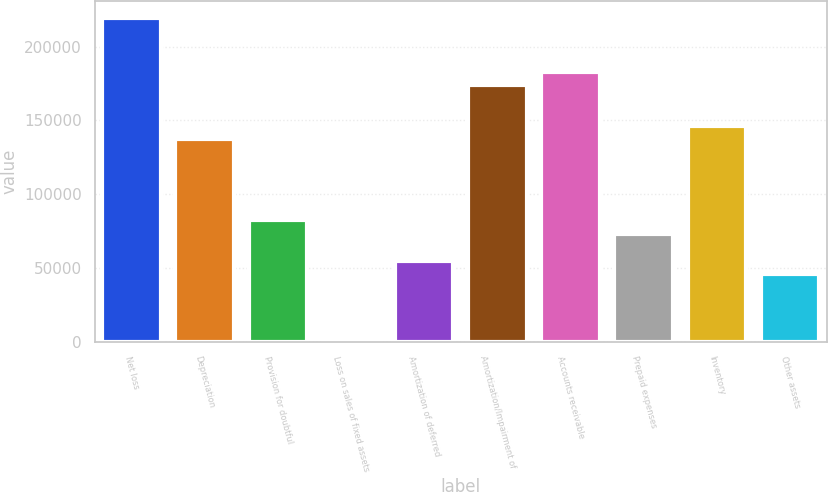Convert chart to OTSL. <chart><loc_0><loc_0><loc_500><loc_500><bar_chart><fcel>Net loss<fcel>Depreciation<fcel>Provision for doubtful<fcel>Loss on sales of fixed assets<fcel>Amortization of deferred<fcel>Amortization/Impairment of<fcel>Accounts receivable<fcel>Prepaid expenses<fcel>Inventory<fcel>Other assets<nl><fcel>219814<fcel>137386<fcel>82433.3<fcel>5<fcel>54957.2<fcel>174020<fcel>183179<fcel>73274.6<fcel>146544<fcel>45798.5<nl></chart> 